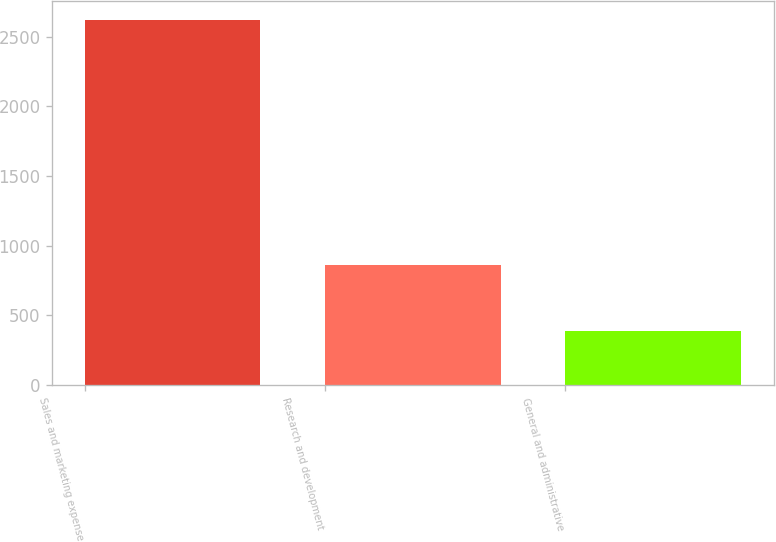Convert chart to OTSL. <chart><loc_0><loc_0><loc_500><loc_500><bar_chart><fcel>Sales and marketing expense<fcel>Research and development<fcel>General and administrative<nl><fcel>2622<fcel>862<fcel>390<nl></chart> 